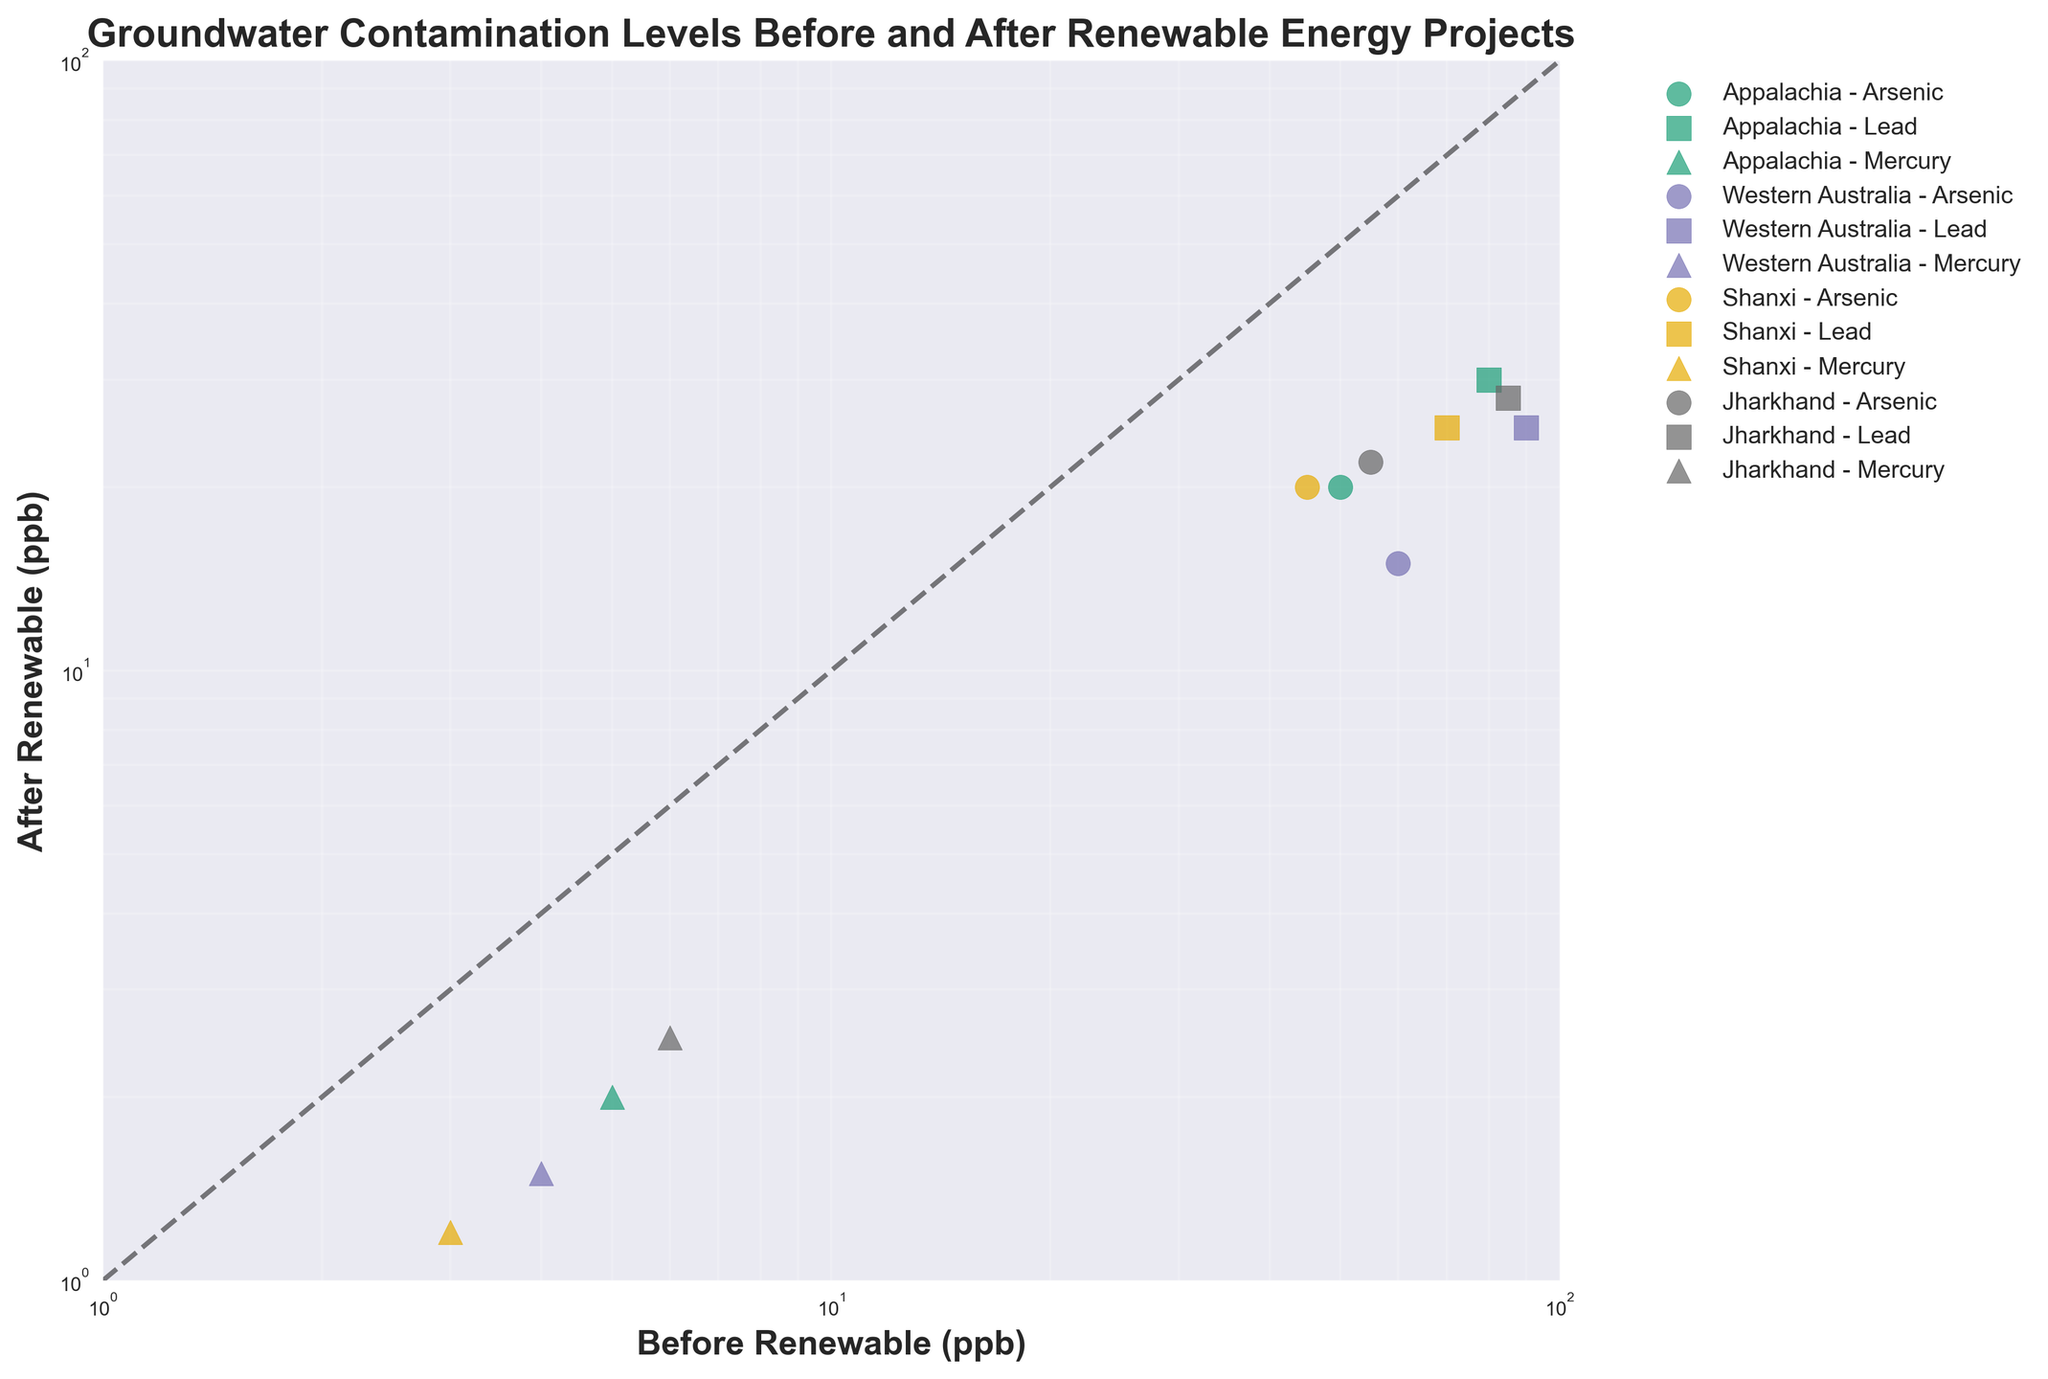What is the title of the figure? The title is typically found at the top of the figure. In this case, it reads, "Groundwater Contamination Levels Before and After Renewable Energy Projects".
Answer: Groundwater Contamination Levels Before and After Renewable Energy Projects What contaminant has the lowest contamination levels after the introduction of renewable energy projects in 2020? Look for the 2020 data points. The plot uses different markers for different contaminants. The one with the lowest after-renewable ppb level is Mercury, which is at 1.2 ppb.
Answer: Mercury Which region shows the greatest reduction in Lead contamination levels after the implementation of renewable energy projects? Identify data points related to Lead contamination for each region and compare the before and after levels. Appalachia has the greatest reduction in Lead contamination from 80 ppb to 30 ppb.
Answer: Appalachia In which region and year did Arsenic contamination levels decrease the most after renewable energy projects were introduced? Compare the before and after Arsenic levels for each region and year. Western Australia in 2015 showed the biggest reduction from 60 ppb to 15 ppb, a 45 ppb decrease.
Answer: Western Australia, 2015 What is the log-log relationship between contamination levels before and after renewable energy projects? The plot shows both axes in a log scale, and a dashed line is drawn at the 1:1 ratio. Examining data points around this line helps assess the relationship, confirming the after levels are generally lower.
Answer: After levels are generally lower How do the contamination levels of Mercury before and after renewable projects compare relative to other contaminants? Look at the plot for Mercury data points. They show lower before and after contamination levels compared to Arsenic and Lead across all regions.
Answer: Generally lower Which region has the highest contamination level reduction for multiple contaminants? By scanning the color/marker scheme, Western Australia in 2015 shows significant reductions for Arsenic, Lead, and Mercury.
Answer: Western Australia What is the common contamination reduction trend visible across all regions and contaminants? All regions and contaminants show a reduction in contamination levels if we compare positions of data points before and after the introduction of renewable projects.
Answer: Reduction in contamination Are any contamination levels the same before and after the renewable energy projects? All data points lie below the 1:1 line on the log-log scale, indicating no levels are the same. Every after point is lower than the before point.
Answer: No levels are the same 